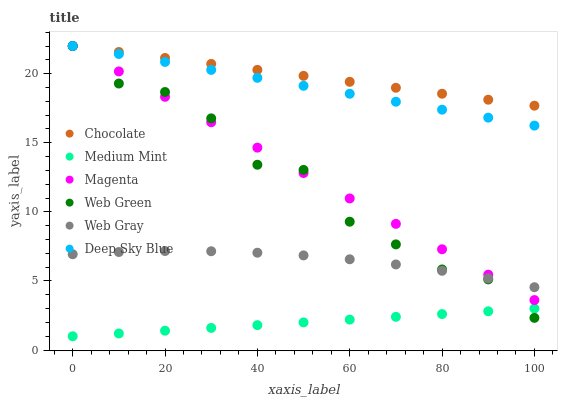Does Medium Mint have the minimum area under the curve?
Answer yes or no. Yes. Does Chocolate have the maximum area under the curve?
Answer yes or no. Yes. Does Web Gray have the minimum area under the curve?
Answer yes or no. No. Does Web Gray have the maximum area under the curve?
Answer yes or no. No. Is Chocolate the smoothest?
Answer yes or no. Yes. Is Web Green the roughest?
Answer yes or no. Yes. Is Web Gray the smoothest?
Answer yes or no. No. Is Web Gray the roughest?
Answer yes or no. No. Does Medium Mint have the lowest value?
Answer yes or no. Yes. Does Web Gray have the lowest value?
Answer yes or no. No. Does Magenta have the highest value?
Answer yes or no. Yes. Does Web Gray have the highest value?
Answer yes or no. No. Is Medium Mint less than Deep Sky Blue?
Answer yes or no. Yes. Is Deep Sky Blue greater than Web Gray?
Answer yes or no. Yes. Does Web Gray intersect Web Green?
Answer yes or no. Yes. Is Web Gray less than Web Green?
Answer yes or no. No. Is Web Gray greater than Web Green?
Answer yes or no. No. Does Medium Mint intersect Deep Sky Blue?
Answer yes or no. No. 